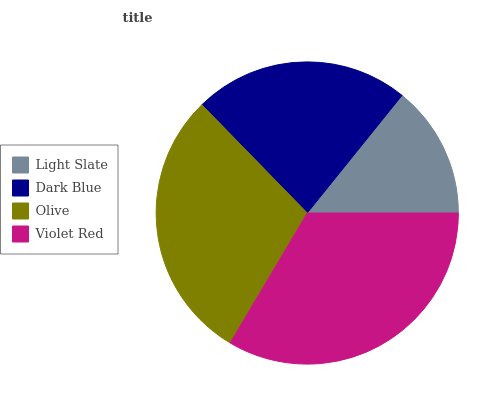Is Light Slate the minimum?
Answer yes or no. Yes. Is Violet Red the maximum?
Answer yes or no. Yes. Is Dark Blue the minimum?
Answer yes or no. No. Is Dark Blue the maximum?
Answer yes or no. No. Is Dark Blue greater than Light Slate?
Answer yes or no. Yes. Is Light Slate less than Dark Blue?
Answer yes or no. Yes. Is Light Slate greater than Dark Blue?
Answer yes or no. No. Is Dark Blue less than Light Slate?
Answer yes or no. No. Is Olive the high median?
Answer yes or no. Yes. Is Dark Blue the low median?
Answer yes or no. Yes. Is Dark Blue the high median?
Answer yes or no. No. Is Violet Red the low median?
Answer yes or no. No. 